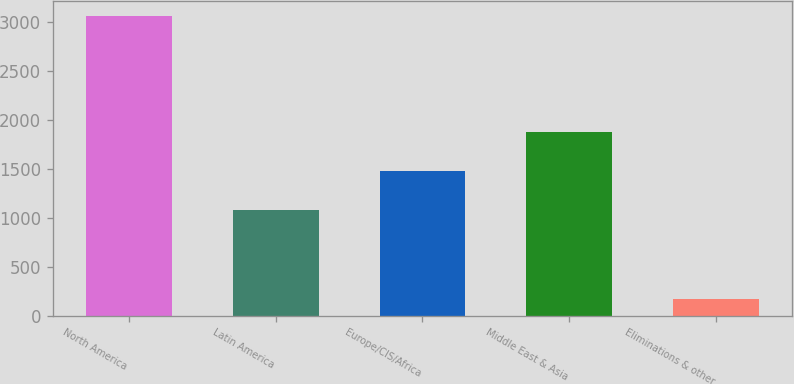Convert chart to OTSL. <chart><loc_0><loc_0><loc_500><loc_500><bar_chart><fcel>North America<fcel>Latin America<fcel>Europe/CIS/Africa<fcel>Middle East & Asia<fcel>Eliminations & other<nl><fcel>3052<fcel>1074<fcel>1477<fcel>1874<fcel>172<nl></chart> 